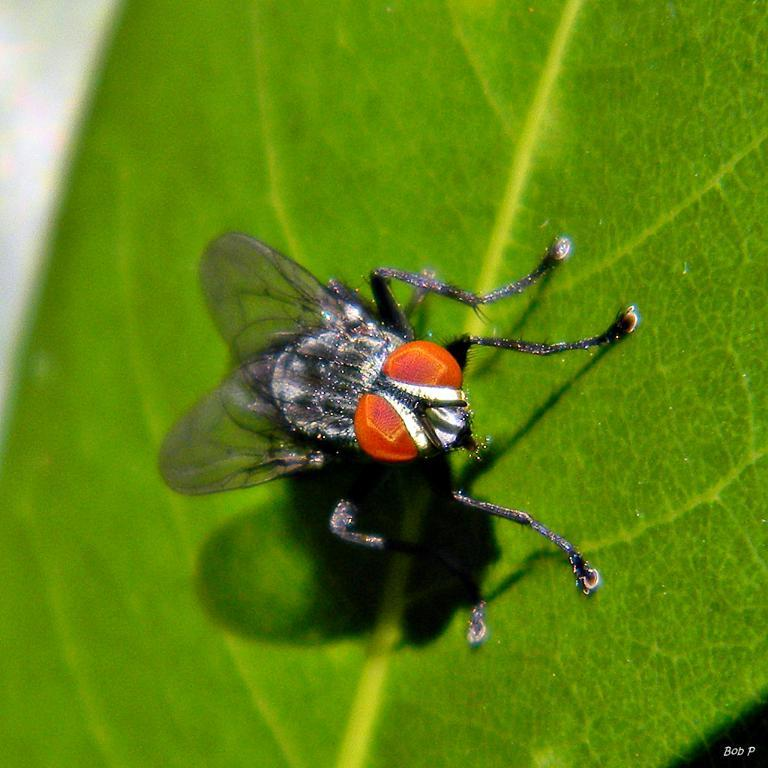What is present on the leaf in the image? There is a black housefly on the leaf in the image. What color is the leaf in the image? The leaf in the image is green. Can you describe the overall quality of the image? The image may be slightly blurry. What type of brass instrument can be seen in the image? There is no brass instrument present in the image; it features a green leaf with a black housefly. 